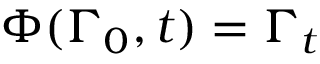<formula> <loc_0><loc_0><loc_500><loc_500>\Phi ( \Gamma _ { 0 } , t ) = \Gamma _ { t }</formula> 